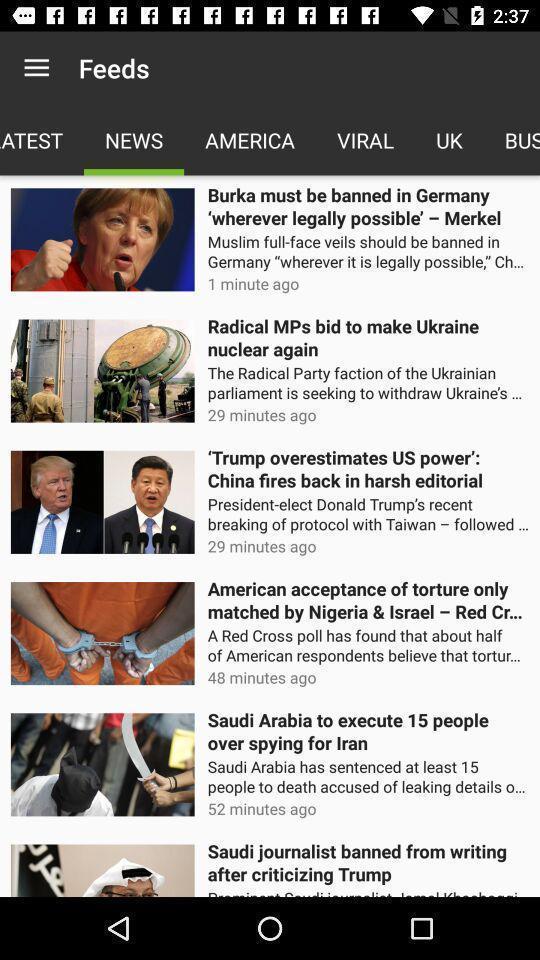Give me a summary of this screen capture. Screen page displaying various articles. 